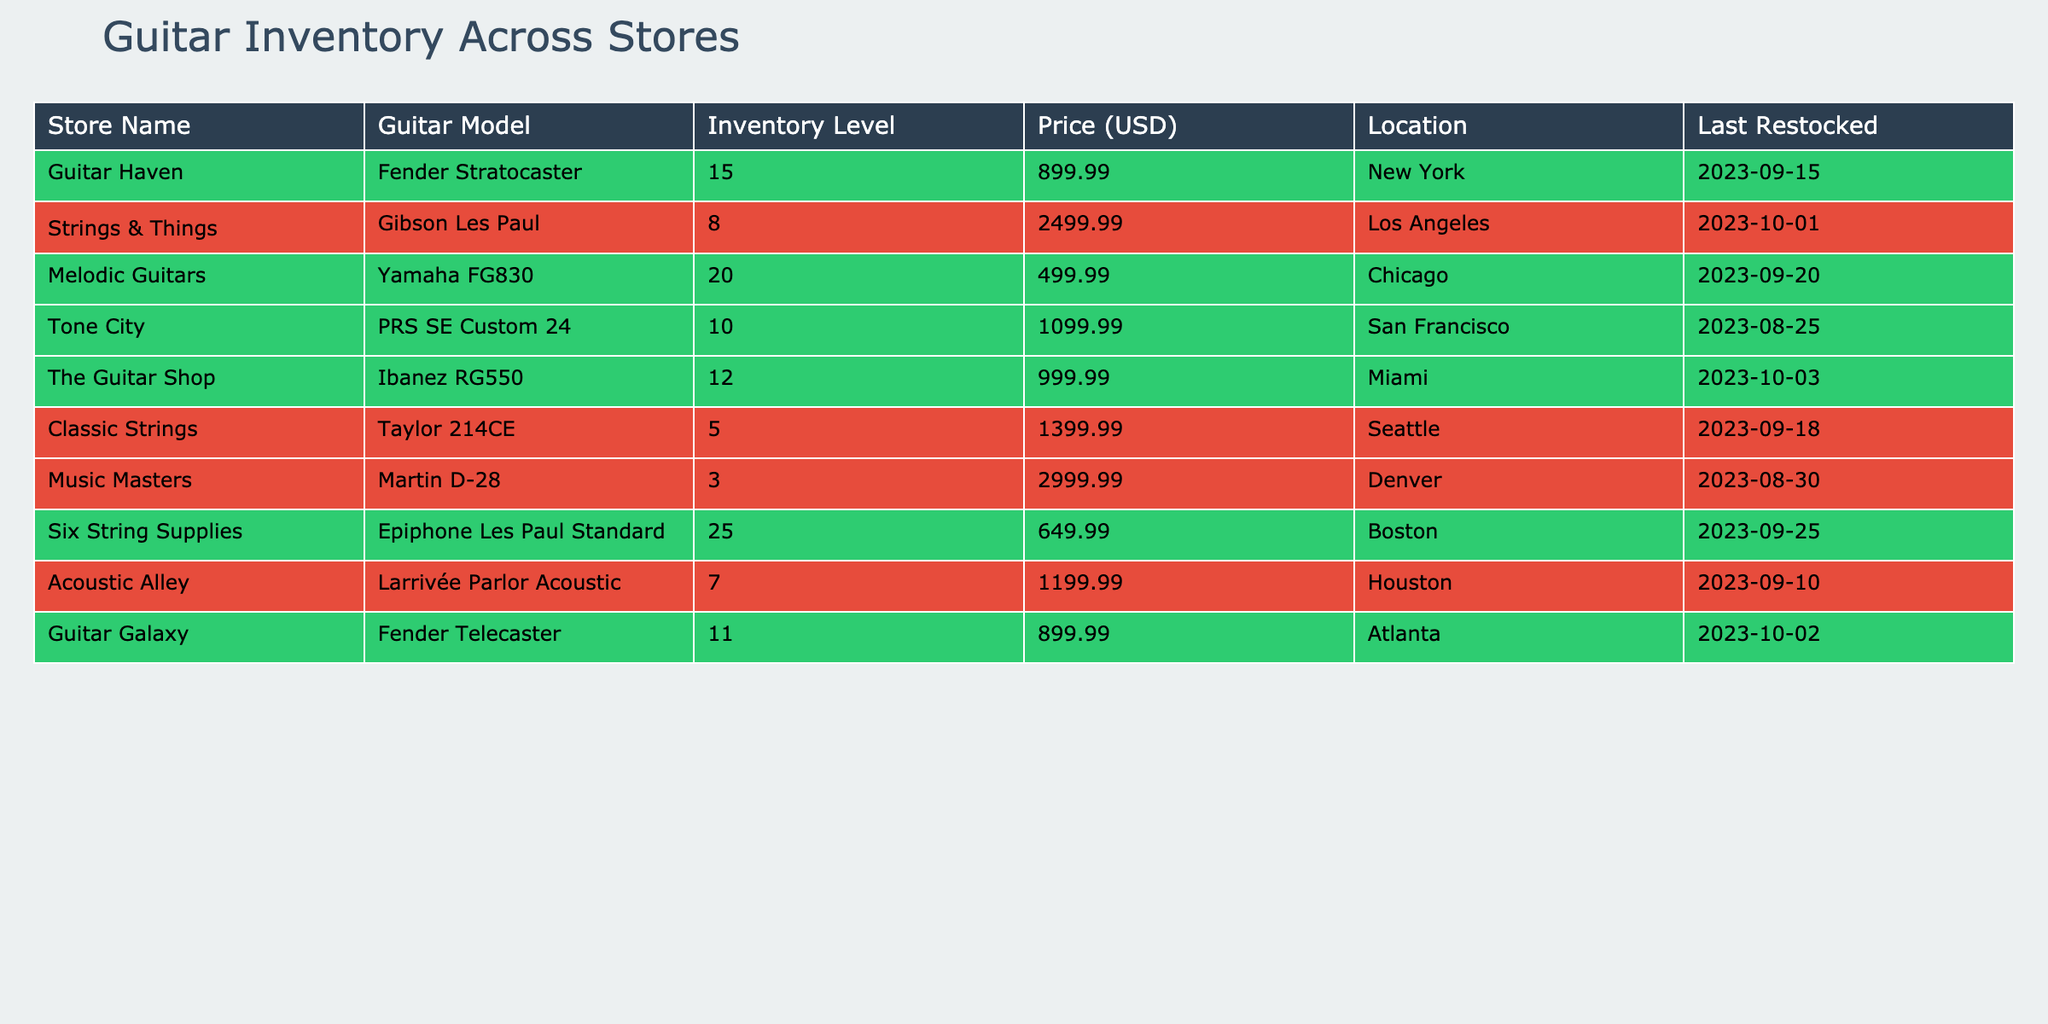What is the highest inventory level for a guitar model across all stores? The highest inventory level can be found by looking through the "Inventory Level" column. The maximum value is 25 for the Epiphone Les Paul Standard at Six String Supplies.
Answer: 25 Which store has the most expensive guitar model? To find the most expensive guitar, look at the "Price (USD)" column. The highest price is 2999.99 for the Martin D-28 at Music Masters.
Answer: Music Masters How many guitar models have an inventory level lower than 10? By examining the "Inventory Level" column, the models with levels lower than 10 are the Martin D-28, Taylor 214CE, and Acoustic Alley. Counting these gives us 3 models.
Answer: 3 What is the total inventory level of guitar models located in Chicago? The only guitar model in Chicago is the Yamaha FG830 with an inventory level of 20, so the total inventory for this location is simply 20.
Answer: 20 Is there any store with a guitar model that has not been restocked recently? The last restocked date for all guitar models can be checked. The Martin D-28 has the earliest restock date of 2023-08-30, indicating it may not have been restocked recently compared to others.
Answer: Yes What is the average price of the guitars across all stores? To calculate the average price, sum all prices (899.99 + 2499.99 + 499.99 + 1099.99 + 999.99 + 1399.99 + 2999.99 + 649.99 + 1199.99 + 899.99), which totals 9999.91. There are 9 guitar models, so the average price is 9999.91 / 9 ≈ 1111.10.
Answer: 1111.10 How many stores have guitar models with an inventory level of 10 or more? Check the "Inventory Level" for each store. The stores with inventory levels of 10 or more are Guitar Haven, Melodic Guitars, Six String Supplies, and Guitar Galaxy, totaling 4 stores.
Answer: 4 Which guitar model in New York has the lowest inventory level? The only guitar model in New York is the Fender Stratocaster, which has an inventory level of 15. Since it is the only model listed, it is also the lowest.
Answer: 15 What is the difference in inventory levels between the most stocked and the least stocked guitar model? The most stocked model is the Epiphone Les Paul Standard with 25 inventory, and the least stocked is the Martin D-28 with 3. The difference is 25 - 3 = 22.
Answer: 22 Are there more guitar types with prices over $1000 or under $1000? By checking the prices, the following models are over $1000: Gibson Les Paul, PRS SE Custom 24, Ibanez RG550, Taylor 214CE, Martin D-28, and Larrivée Parlor Acoustic. There are 6 models over $1000 and 3 models under $1000, indicating more types over $1000.
Answer: Yes 